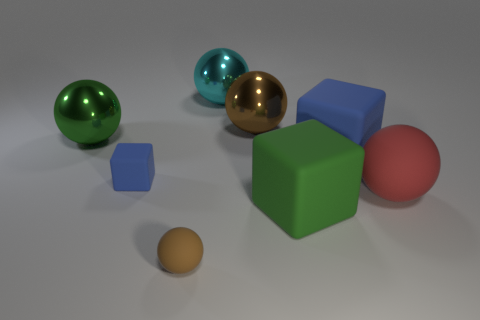Could you suggest what the lighting conditions indicate about the setting in which the objects are placed? The lighting in the image is soft and diffuse, with gentle shadows beneath the objects suggesting ambient lighting conditions, perhaps coming from a source above and slightly to the front of the objects. This setup is often used in product photography to enhance the object's features without harsh shadows, indicating a controlled indoor environment. What time of day does such lighting resemble? Such lighting doesn't resemble natural daylight conditions well, as it's too uniform and lacks the directional quality of sunlight. It's more akin to studio lighting that can be used at any time. 